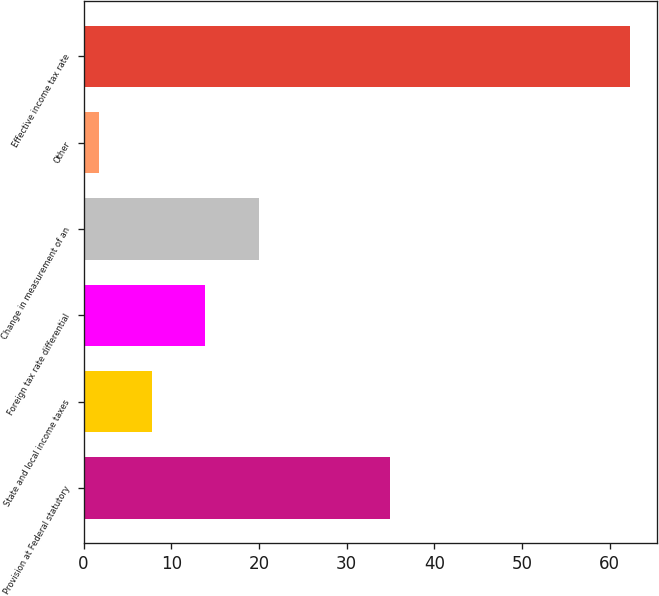<chart> <loc_0><loc_0><loc_500><loc_500><bar_chart><fcel>Provision at Federal statutory<fcel>State and local income taxes<fcel>Foreign tax rate differential<fcel>Change in measurement of an<fcel>Other<fcel>Effective income tax rate<nl><fcel>35<fcel>7.85<fcel>13.9<fcel>19.95<fcel>1.8<fcel>62.3<nl></chart> 